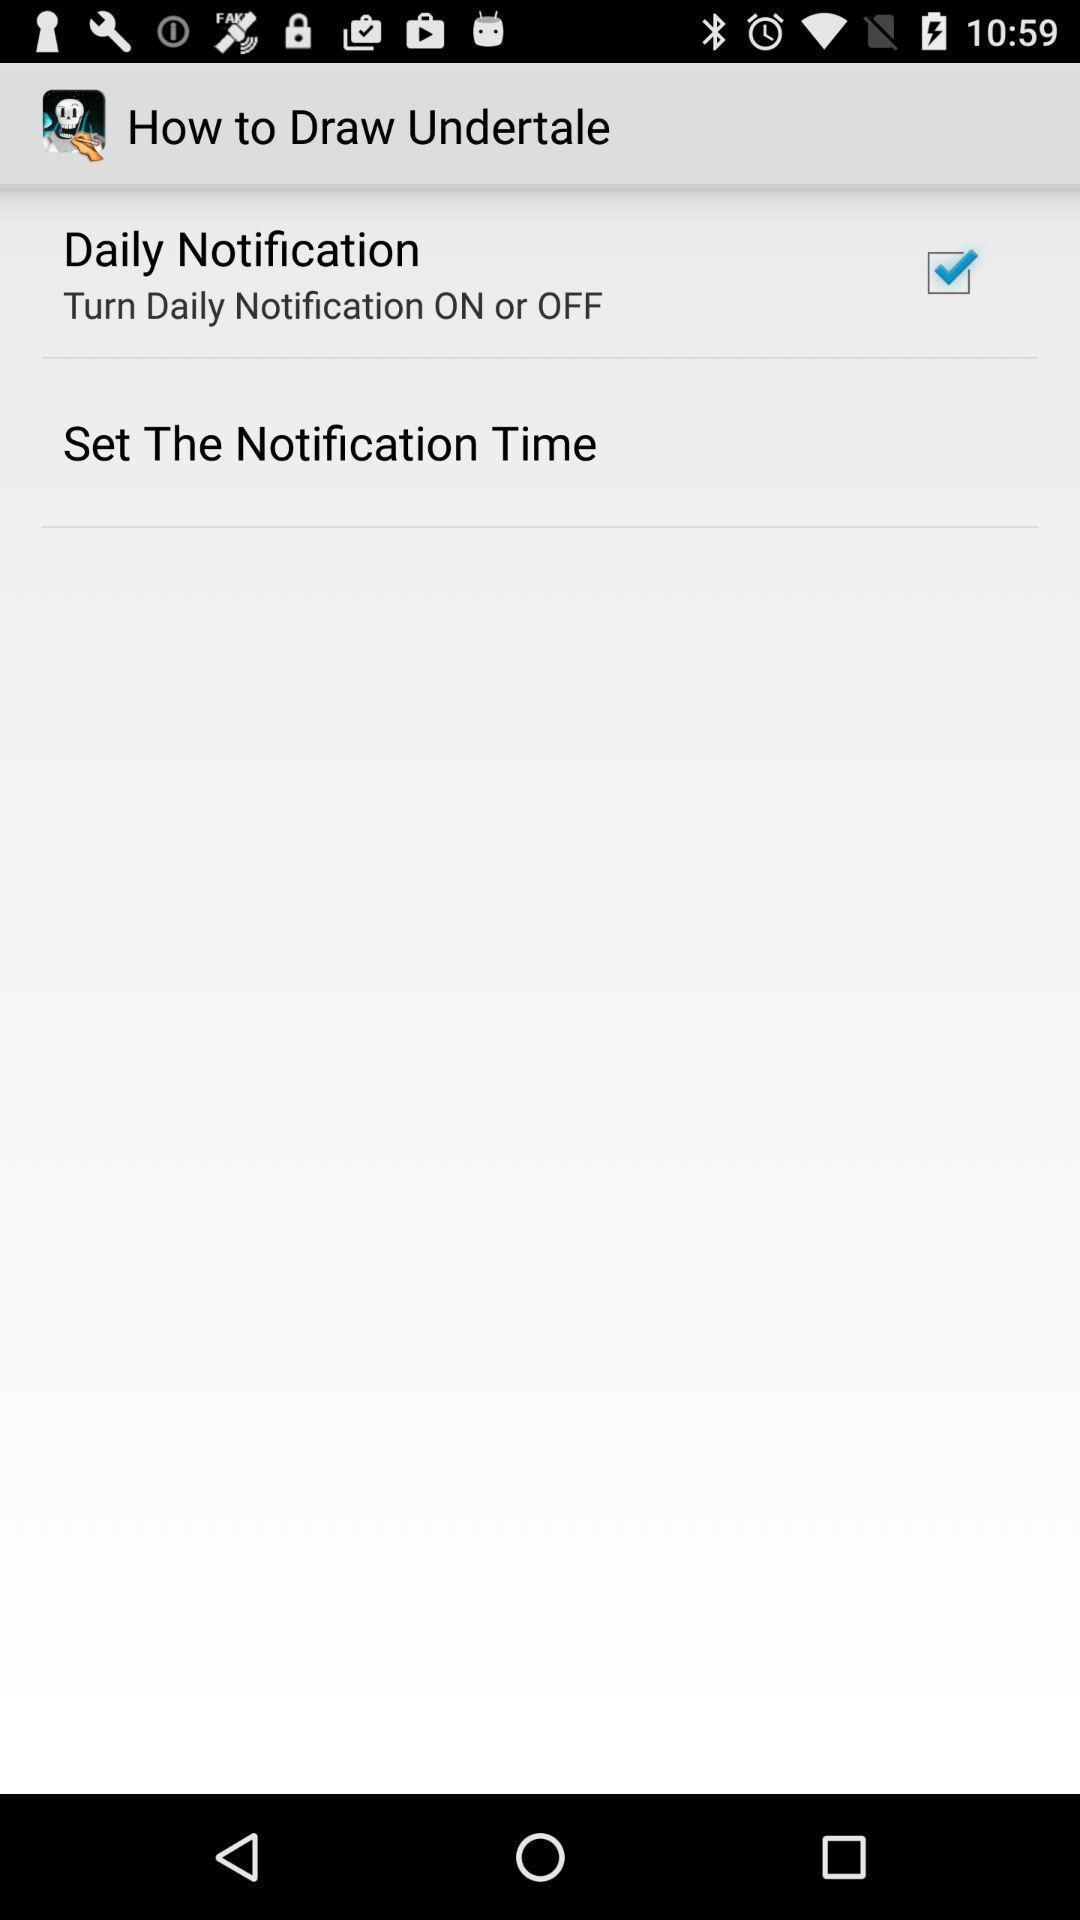Describe the visual elements of this screenshot. Screen display notification settings. 